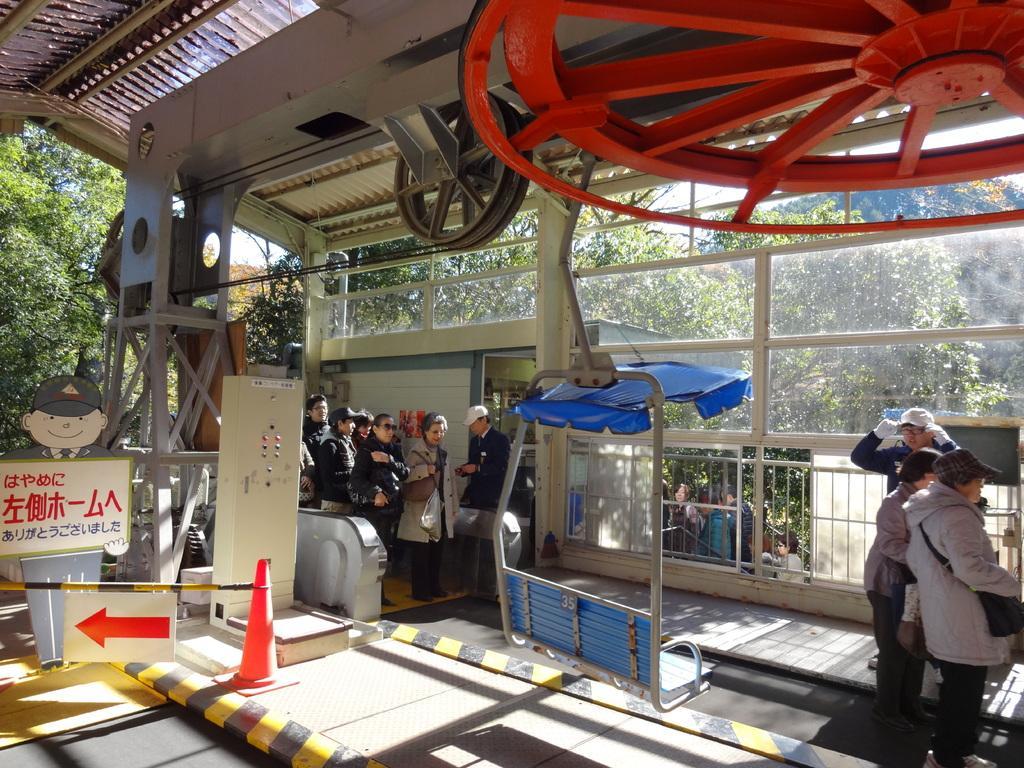Please provide a concise description of this image. In this image, I can see groups of people standing on the floor. On the left side of the image, I can see a direction board, a traffic cone and few other objects. I can see a chairlift to a rod, iron grilles and glass windows. At the top of the image, there are wheels to a ceiling. In the background, there are trees. 